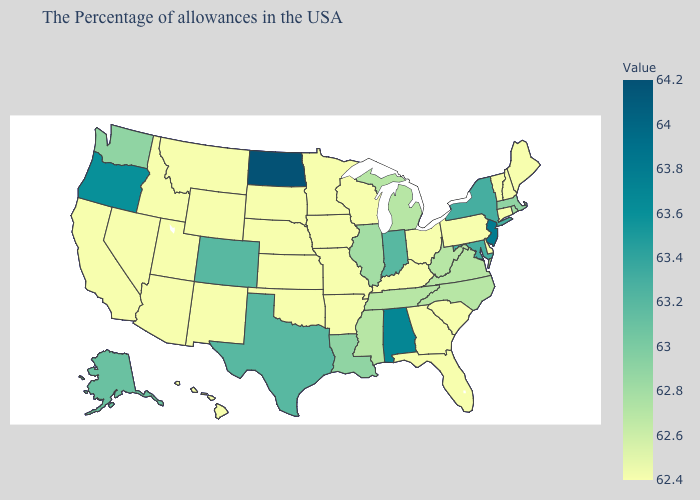Among the states that border Vermont , does New Hampshire have the lowest value?
Write a very short answer. Yes. Which states hav the highest value in the MidWest?
Give a very brief answer. North Dakota. Does Iowa have a higher value than Michigan?
Short answer required. No. Does the map have missing data?
Quick response, please. No. Among the states that border Arizona , does Colorado have the lowest value?
Quick response, please. No. Does Washington have the highest value in the West?
Short answer required. No. 